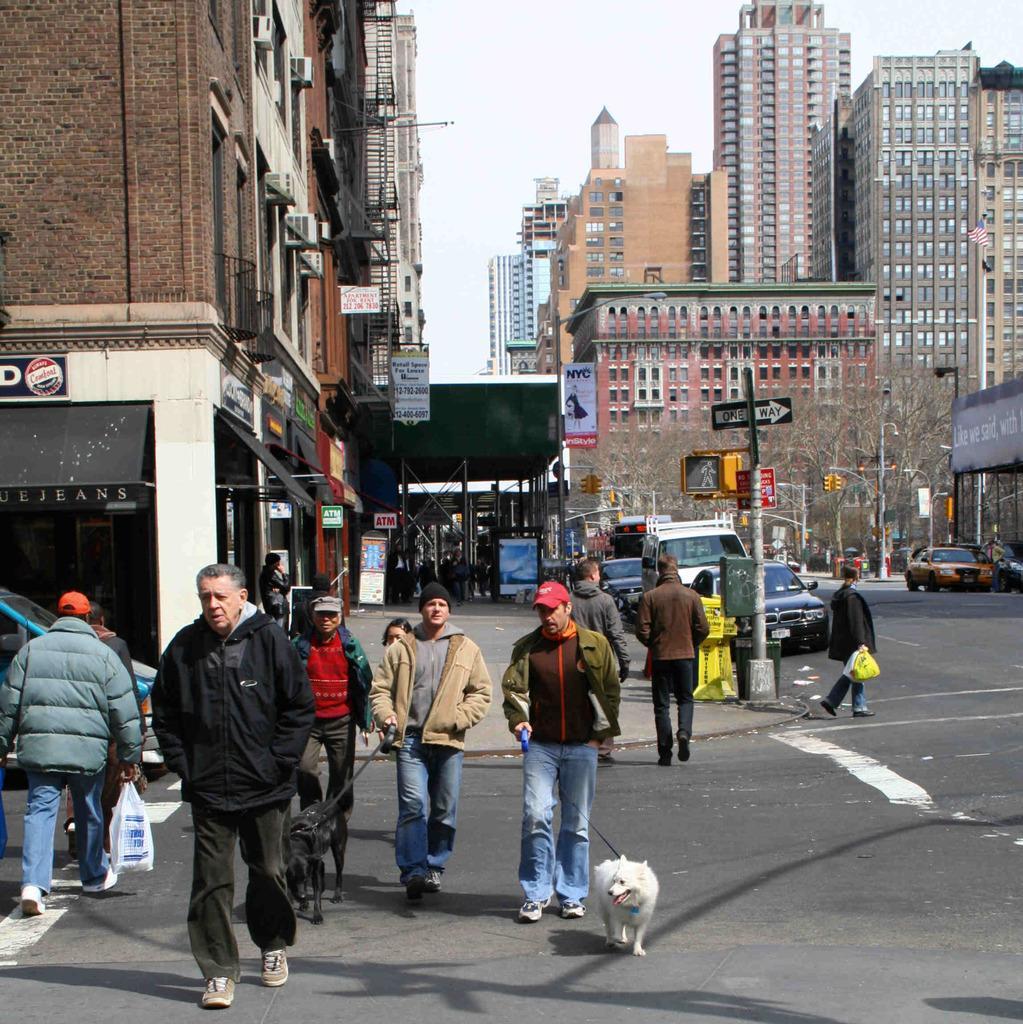Describe this image in one or two sentences. this picture shows few buildings and feel people walking on the road and the we see two people holding dogs in their hand with the help of a string and we see a parked vehicles and couple o trees 